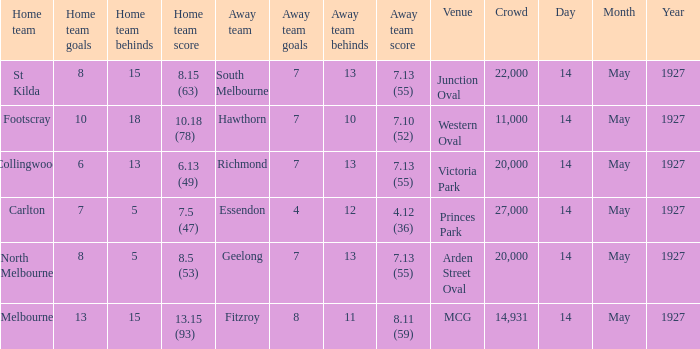On what date does Essendon play as the away team? 14 May 1927. 